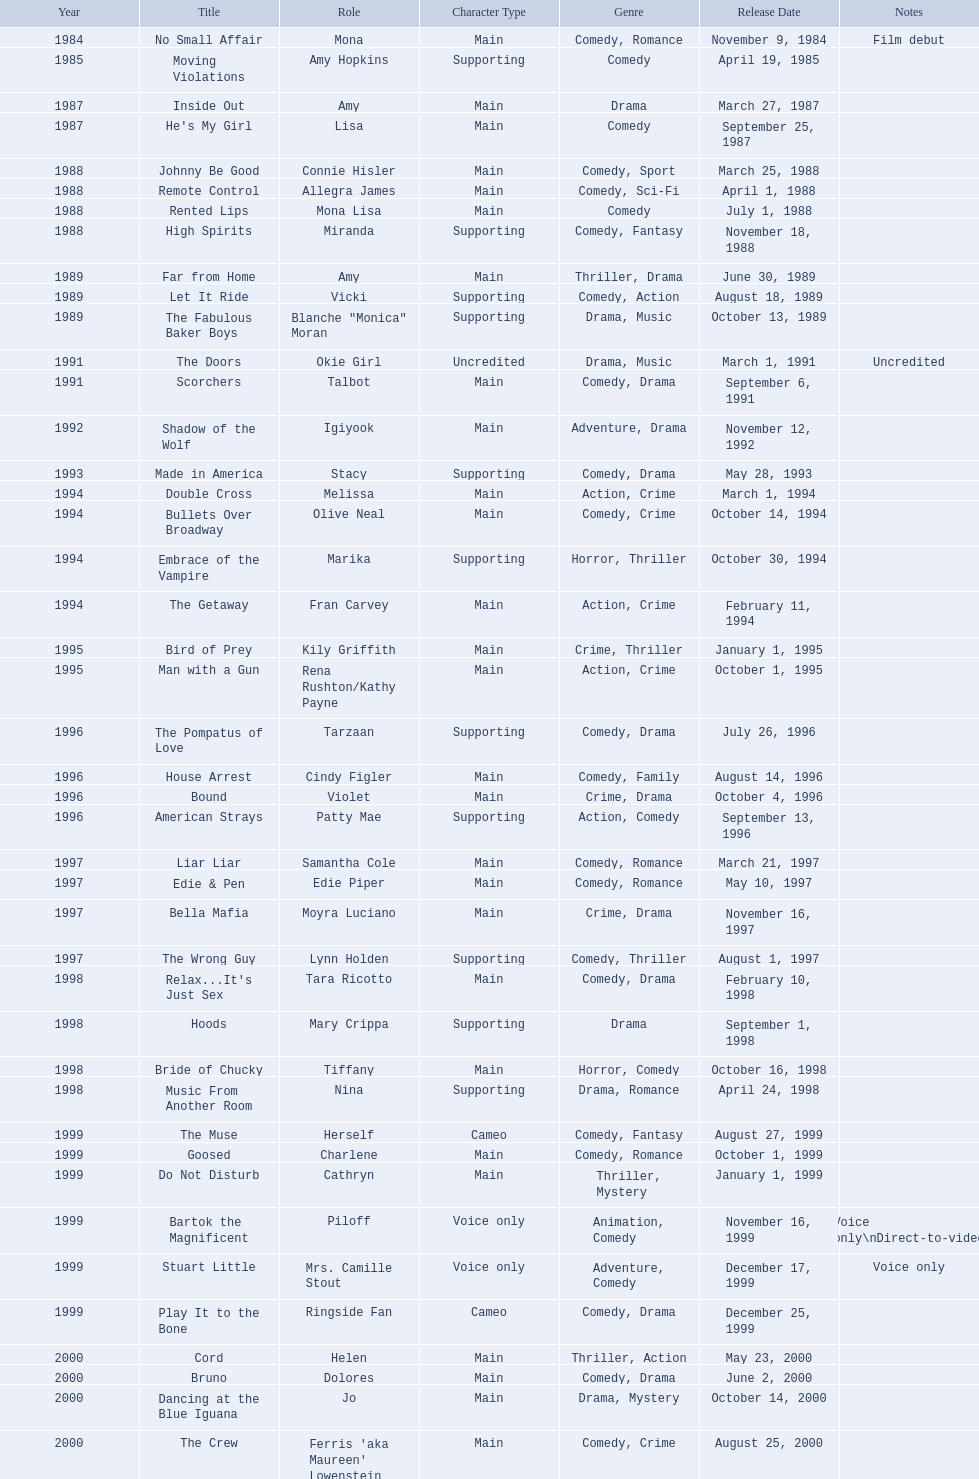Which film has their role under igiyook? Shadow of the Wolf. 